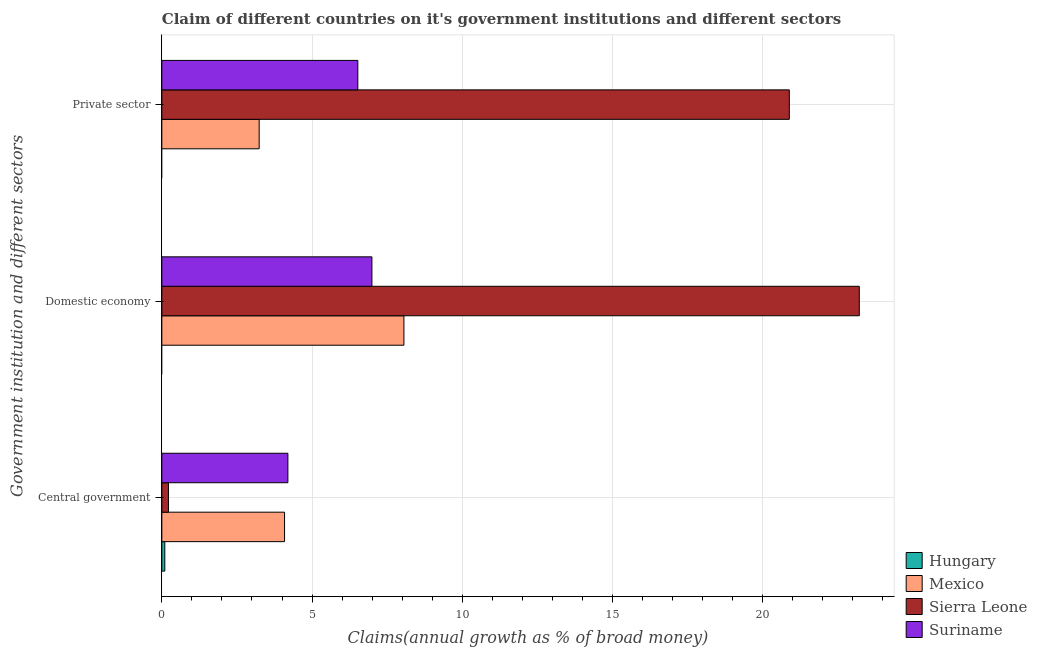How many different coloured bars are there?
Your response must be concise. 4. Are the number of bars on each tick of the Y-axis equal?
Your answer should be very brief. No. What is the label of the 1st group of bars from the top?
Provide a short and direct response. Private sector. What is the percentage of claim on the private sector in Suriname?
Your response must be concise. 6.52. Across all countries, what is the maximum percentage of claim on the central government?
Provide a short and direct response. 4.2. Across all countries, what is the minimum percentage of claim on the central government?
Your answer should be compact. 0.1. In which country was the percentage of claim on the private sector maximum?
Keep it short and to the point. Sierra Leone. What is the total percentage of claim on the central government in the graph?
Offer a very short reply. 8.6. What is the difference between the percentage of claim on the private sector in Sierra Leone and that in Suriname?
Your response must be concise. 14.36. What is the difference between the percentage of claim on the central government in Suriname and the percentage of claim on the domestic economy in Mexico?
Keep it short and to the point. -3.86. What is the average percentage of claim on the private sector per country?
Make the answer very short. 7.66. What is the difference between the percentage of claim on the private sector and percentage of claim on the domestic economy in Suriname?
Provide a succinct answer. -0.47. What is the ratio of the percentage of claim on the domestic economy in Sierra Leone to that in Mexico?
Offer a terse response. 2.88. Is the percentage of claim on the private sector in Sierra Leone less than that in Suriname?
Give a very brief answer. No. Is the difference between the percentage of claim on the domestic economy in Suriname and Mexico greater than the difference between the percentage of claim on the private sector in Suriname and Mexico?
Provide a short and direct response. No. What is the difference between the highest and the second highest percentage of claim on the private sector?
Provide a succinct answer. 14.36. What is the difference between the highest and the lowest percentage of claim on the domestic economy?
Keep it short and to the point. 23.21. In how many countries, is the percentage of claim on the central government greater than the average percentage of claim on the central government taken over all countries?
Provide a short and direct response. 2. Is the sum of the percentage of claim on the domestic economy in Sierra Leone and Mexico greater than the maximum percentage of claim on the private sector across all countries?
Give a very brief answer. Yes. How many bars are there?
Your answer should be compact. 10. Are all the bars in the graph horizontal?
Provide a short and direct response. Yes. How many countries are there in the graph?
Give a very brief answer. 4. Are the values on the major ticks of X-axis written in scientific E-notation?
Offer a very short reply. No. Does the graph contain grids?
Offer a very short reply. Yes. Where does the legend appear in the graph?
Offer a terse response. Bottom right. What is the title of the graph?
Offer a terse response. Claim of different countries on it's government institutions and different sectors. Does "Kazakhstan" appear as one of the legend labels in the graph?
Make the answer very short. No. What is the label or title of the X-axis?
Your answer should be compact. Claims(annual growth as % of broad money). What is the label or title of the Y-axis?
Make the answer very short. Government institution and different sectors. What is the Claims(annual growth as % of broad money) in Hungary in Central government?
Your answer should be very brief. 0.1. What is the Claims(annual growth as % of broad money) in Mexico in Central government?
Your response must be concise. 4.08. What is the Claims(annual growth as % of broad money) in Sierra Leone in Central government?
Your answer should be very brief. 0.22. What is the Claims(annual growth as % of broad money) of Suriname in Central government?
Your answer should be very brief. 4.2. What is the Claims(annual growth as % of broad money) in Hungary in Domestic economy?
Keep it short and to the point. 0. What is the Claims(annual growth as % of broad money) in Mexico in Domestic economy?
Provide a short and direct response. 8.06. What is the Claims(annual growth as % of broad money) in Sierra Leone in Domestic economy?
Keep it short and to the point. 23.21. What is the Claims(annual growth as % of broad money) of Suriname in Domestic economy?
Keep it short and to the point. 6.99. What is the Claims(annual growth as % of broad money) of Hungary in Private sector?
Give a very brief answer. 0. What is the Claims(annual growth as % of broad money) of Mexico in Private sector?
Your response must be concise. 3.24. What is the Claims(annual growth as % of broad money) in Sierra Leone in Private sector?
Make the answer very short. 20.88. What is the Claims(annual growth as % of broad money) in Suriname in Private sector?
Ensure brevity in your answer.  6.52. Across all Government institution and different sectors, what is the maximum Claims(annual growth as % of broad money) of Hungary?
Give a very brief answer. 0.1. Across all Government institution and different sectors, what is the maximum Claims(annual growth as % of broad money) of Mexico?
Offer a very short reply. 8.06. Across all Government institution and different sectors, what is the maximum Claims(annual growth as % of broad money) in Sierra Leone?
Your response must be concise. 23.21. Across all Government institution and different sectors, what is the maximum Claims(annual growth as % of broad money) in Suriname?
Your answer should be compact. 6.99. Across all Government institution and different sectors, what is the minimum Claims(annual growth as % of broad money) in Mexico?
Provide a short and direct response. 3.24. Across all Government institution and different sectors, what is the minimum Claims(annual growth as % of broad money) in Sierra Leone?
Ensure brevity in your answer.  0.22. Across all Government institution and different sectors, what is the minimum Claims(annual growth as % of broad money) in Suriname?
Provide a succinct answer. 4.2. What is the total Claims(annual growth as % of broad money) of Hungary in the graph?
Offer a terse response. 0.1. What is the total Claims(annual growth as % of broad money) of Mexico in the graph?
Give a very brief answer. 15.38. What is the total Claims(annual growth as % of broad money) in Sierra Leone in the graph?
Your answer should be compact. 44.32. What is the total Claims(annual growth as % of broad money) of Suriname in the graph?
Offer a very short reply. 17.71. What is the difference between the Claims(annual growth as % of broad money) in Mexico in Central government and that in Domestic economy?
Offer a terse response. -3.97. What is the difference between the Claims(annual growth as % of broad money) in Sierra Leone in Central government and that in Domestic economy?
Provide a short and direct response. -22.99. What is the difference between the Claims(annual growth as % of broad money) of Suriname in Central government and that in Domestic economy?
Ensure brevity in your answer.  -2.8. What is the difference between the Claims(annual growth as % of broad money) of Mexico in Central government and that in Private sector?
Provide a succinct answer. 0.84. What is the difference between the Claims(annual growth as % of broad money) in Sierra Leone in Central government and that in Private sector?
Your answer should be compact. -20.66. What is the difference between the Claims(annual growth as % of broad money) of Suriname in Central government and that in Private sector?
Make the answer very short. -2.33. What is the difference between the Claims(annual growth as % of broad money) of Mexico in Domestic economy and that in Private sector?
Your answer should be very brief. 4.82. What is the difference between the Claims(annual growth as % of broad money) of Sierra Leone in Domestic economy and that in Private sector?
Ensure brevity in your answer.  2.33. What is the difference between the Claims(annual growth as % of broad money) of Suriname in Domestic economy and that in Private sector?
Give a very brief answer. 0.47. What is the difference between the Claims(annual growth as % of broad money) of Hungary in Central government and the Claims(annual growth as % of broad money) of Mexico in Domestic economy?
Offer a terse response. -7.96. What is the difference between the Claims(annual growth as % of broad money) of Hungary in Central government and the Claims(annual growth as % of broad money) of Sierra Leone in Domestic economy?
Keep it short and to the point. -23.11. What is the difference between the Claims(annual growth as % of broad money) of Hungary in Central government and the Claims(annual growth as % of broad money) of Suriname in Domestic economy?
Your response must be concise. -6.89. What is the difference between the Claims(annual growth as % of broad money) in Mexico in Central government and the Claims(annual growth as % of broad money) in Sierra Leone in Domestic economy?
Provide a succinct answer. -19.13. What is the difference between the Claims(annual growth as % of broad money) of Mexico in Central government and the Claims(annual growth as % of broad money) of Suriname in Domestic economy?
Provide a succinct answer. -2.91. What is the difference between the Claims(annual growth as % of broad money) in Sierra Leone in Central government and the Claims(annual growth as % of broad money) in Suriname in Domestic economy?
Provide a succinct answer. -6.77. What is the difference between the Claims(annual growth as % of broad money) in Hungary in Central government and the Claims(annual growth as % of broad money) in Mexico in Private sector?
Give a very brief answer. -3.14. What is the difference between the Claims(annual growth as % of broad money) of Hungary in Central government and the Claims(annual growth as % of broad money) of Sierra Leone in Private sector?
Keep it short and to the point. -20.79. What is the difference between the Claims(annual growth as % of broad money) in Hungary in Central government and the Claims(annual growth as % of broad money) in Suriname in Private sector?
Keep it short and to the point. -6.42. What is the difference between the Claims(annual growth as % of broad money) in Mexico in Central government and the Claims(annual growth as % of broad money) in Sierra Leone in Private sector?
Provide a short and direct response. -16.8. What is the difference between the Claims(annual growth as % of broad money) of Mexico in Central government and the Claims(annual growth as % of broad money) of Suriname in Private sector?
Ensure brevity in your answer.  -2.44. What is the difference between the Claims(annual growth as % of broad money) in Sierra Leone in Central government and the Claims(annual growth as % of broad money) in Suriname in Private sector?
Offer a terse response. -6.3. What is the difference between the Claims(annual growth as % of broad money) of Mexico in Domestic economy and the Claims(annual growth as % of broad money) of Sierra Leone in Private sector?
Provide a short and direct response. -12.83. What is the difference between the Claims(annual growth as % of broad money) in Mexico in Domestic economy and the Claims(annual growth as % of broad money) in Suriname in Private sector?
Give a very brief answer. 1.53. What is the difference between the Claims(annual growth as % of broad money) of Sierra Leone in Domestic economy and the Claims(annual growth as % of broad money) of Suriname in Private sector?
Make the answer very short. 16.69. What is the average Claims(annual growth as % of broad money) of Hungary per Government institution and different sectors?
Your answer should be very brief. 0.03. What is the average Claims(annual growth as % of broad money) of Mexico per Government institution and different sectors?
Provide a short and direct response. 5.13. What is the average Claims(annual growth as % of broad money) of Sierra Leone per Government institution and different sectors?
Provide a succinct answer. 14.77. What is the average Claims(annual growth as % of broad money) of Suriname per Government institution and different sectors?
Your answer should be very brief. 5.9. What is the difference between the Claims(annual growth as % of broad money) in Hungary and Claims(annual growth as % of broad money) in Mexico in Central government?
Ensure brevity in your answer.  -3.98. What is the difference between the Claims(annual growth as % of broad money) of Hungary and Claims(annual growth as % of broad money) of Sierra Leone in Central government?
Your answer should be compact. -0.12. What is the difference between the Claims(annual growth as % of broad money) of Hungary and Claims(annual growth as % of broad money) of Suriname in Central government?
Provide a succinct answer. -4.1. What is the difference between the Claims(annual growth as % of broad money) in Mexico and Claims(annual growth as % of broad money) in Sierra Leone in Central government?
Offer a very short reply. 3.86. What is the difference between the Claims(annual growth as % of broad money) of Mexico and Claims(annual growth as % of broad money) of Suriname in Central government?
Offer a terse response. -0.11. What is the difference between the Claims(annual growth as % of broad money) of Sierra Leone and Claims(annual growth as % of broad money) of Suriname in Central government?
Offer a terse response. -3.98. What is the difference between the Claims(annual growth as % of broad money) of Mexico and Claims(annual growth as % of broad money) of Sierra Leone in Domestic economy?
Give a very brief answer. -15.16. What is the difference between the Claims(annual growth as % of broad money) in Mexico and Claims(annual growth as % of broad money) in Suriname in Domestic economy?
Keep it short and to the point. 1.07. What is the difference between the Claims(annual growth as % of broad money) of Sierra Leone and Claims(annual growth as % of broad money) of Suriname in Domestic economy?
Ensure brevity in your answer.  16.22. What is the difference between the Claims(annual growth as % of broad money) of Mexico and Claims(annual growth as % of broad money) of Sierra Leone in Private sector?
Your answer should be very brief. -17.65. What is the difference between the Claims(annual growth as % of broad money) of Mexico and Claims(annual growth as % of broad money) of Suriname in Private sector?
Provide a short and direct response. -3.28. What is the difference between the Claims(annual growth as % of broad money) of Sierra Leone and Claims(annual growth as % of broad money) of Suriname in Private sector?
Provide a succinct answer. 14.36. What is the ratio of the Claims(annual growth as % of broad money) of Mexico in Central government to that in Domestic economy?
Your response must be concise. 0.51. What is the ratio of the Claims(annual growth as % of broad money) of Sierra Leone in Central government to that in Domestic economy?
Give a very brief answer. 0.01. What is the ratio of the Claims(annual growth as % of broad money) in Suriname in Central government to that in Domestic economy?
Your answer should be compact. 0.6. What is the ratio of the Claims(annual growth as % of broad money) in Mexico in Central government to that in Private sector?
Provide a succinct answer. 1.26. What is the ratio of the Claims(annual growth as % of broad money) in Sierra Leone in Central government to that in Private sector?
Make the answer very short. 0.01. What is the ratio of the Claims(annual growth as % of broad money) in Suriname in Central government to that in Private sector?
Ensure brevity in your answer.  0.64. What is the ratio of the Claims(annual growth as % of broad money) in Mexico in Domestic economy to that in Private sector?
Offer a terse response. 2.49. What is the ratio of the Claims(annual growth as % of broad money) of Sierra Leone in Domestic economy to that in Private sector?
Your response must be concise. 1.11. What is the ratio of the Claims(annual growth as % of broad money) of Suriname in Domestic economy to that in Private sector?
Offer a terse response. 1.07. What is the difference between the highest and the second highest Claims(annual growth as % of broad money) in Mexico?
Provide a short and direct response. 3.97. What is the difference between the highest and the second highest Claims(annual growth as % of broad money) of Sierra Leone?
Give a very brief answer. 2.33. What is the difference between the highest and the second highest Claims(annual growth as % of broad money) in Suriname?
Keep it short and to the point. 0.47. What is the difference between the highest and the lowest Claims(annual growth as % of broad money) of Hungary?
Keep it short and to the point. 0.1. What is the difference between the highest and the lowest Claims(annual growth as % of broad money) of Mexico?
Your response must be concise. 4.82. What is the difference between the highest and the lowest Claims(annual growth as % of broad money) in Sierra Leone?
Offer a terse response. 22.99. What is the difference between the highest and the lowest Claims(annual growth as % of broad money) in Suriname?
Your response must be concise. 2.8. 